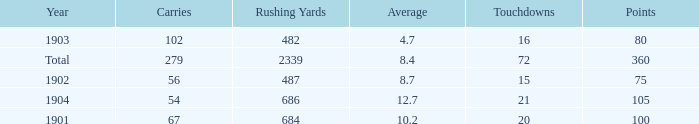How many carries have an average under 8.7 and touchdowns of 72? 1.0. 